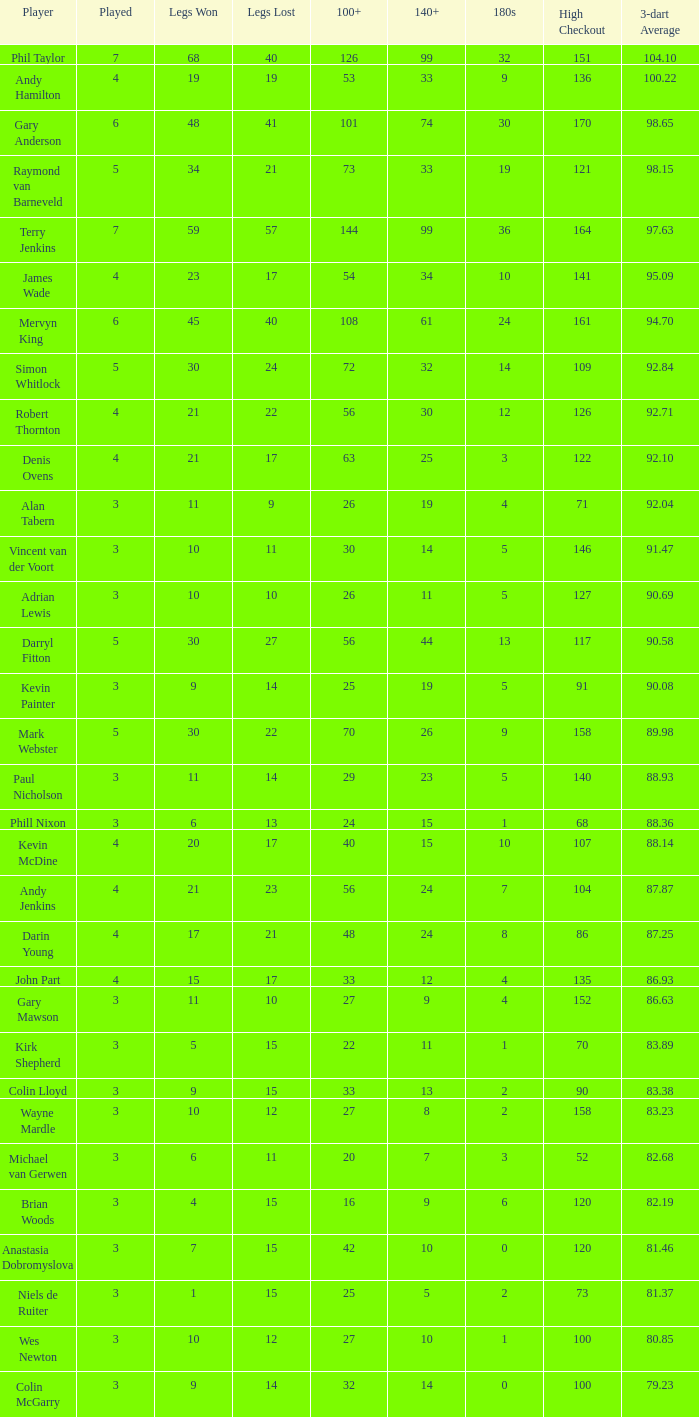What is the played number when the high checkout is 135? 4.0. Give me the full table as a dictionary. {'header': ['Player', 'Played', 'Legs Won', 'Legs Lost', '100+', '140+', '180s', 'High Checkout', '3-dart Average'], 'rows': [['Phil Taylor', '7', '68', '40', '126', '99', '32', '151', '104.10'], ['Andy Hamilton', '4', '19', '19', '53', '33', '9', '136', '100.22'], ['Gary Anderson', '6', '48', '41', '101', '74', '30', '170', '98.65'], ['Raymond van Barneveld', '5', '34', '21', '73', '33', '19', '121', '98.15'], ['Terry Jenkins', '7', '59', '57', '144', '99', '36', '164', '97.63'], ['James Wade', '4', '23', '17', '54', '34', '10', '141', '95.09'], ['Mervyn King', '6', '45', '40', '108', '61', '24', '161', '94.70'], ['Simon Whitlock', '5', '30', '24', '72', '32', '14', '109', '92.84'], ['Robert Thornton', '4', '21', '22', '56', '30', '12', '126', '92.71'], ['Denis Ovens', '4', '21', '17', '63', '25', '3', '122', '92.10'], ['Alan Tabern', '3', '11', '9', '26', '19', '4', '71', '92.04'], ['Vincent van der Voort', '3', '10', '11', '30', '14', '5', '146', '91.47'], ['Adrian Lewis', '3', '10', '10', '26', '11', '5', '127', '90.69'], ['Darryl Fitton', '5', '30', '27', '56', '44', '13', '117', '90.58'], ['Kevin Painter', '3', '9', '14', '25', '19', '5', '91', '90.08'], ['Mark Webster', '5', '30', '22', '70', '26', '9', '158', '89.98'], ['Paul Nicholson', '3', '11', '14', '29', '23', '5', '140', '88.93'], ['Phill Nixon', '3', '6', '13', '24', '15', '1', '68', '88.36'], ['Kevin McDine', '4', '20', '17', '40', '15', '10', '107', '88.14'], ['Andy Jenkins', '4', '21', '23', '56', '24', '7', '104', '87.87'], ['Darin Young', '4', '17', '21', '48', '24', '8', '86', '87.25'], ['John Part', '4', '15', '17', '33', '12', '4', '135', '86.93'], ['Gary Mawson', '3', '11', '10', '27', '9', '4', '152', '86.63'], ['Kirk Shepherd', '3', '5', '15', '22', '11', '1', '70', '83.89'], ['Colin Lloyd', '3', '9', '15', '33', '13', '2', '90', '83.38'], ['Wayne Mardle', '3', '10', '12', '27', '8', '2', '158', '83.23'], ['Michael van Gerwen', '3', '6', '11', '20', '7', '3', '52', '82.68'], ['Brian Woods', '3', '4', '15', '16', '9', '6', '120', '82.19'], ['Anastasia Dobromyslova', '3', '7', '15', '42', '10', '0', '120', '81.46'], ['Niels de Ruiter', '3', '1', '15', '25', '5', '2', '73', '81.37'], ['Wes Newton', '3', '10', '12', '27', '10', '1', '100', '80.85'], ['Colin McGarry', '3', '9', '14', '32', '14', '0', '100', '79.23']]} 